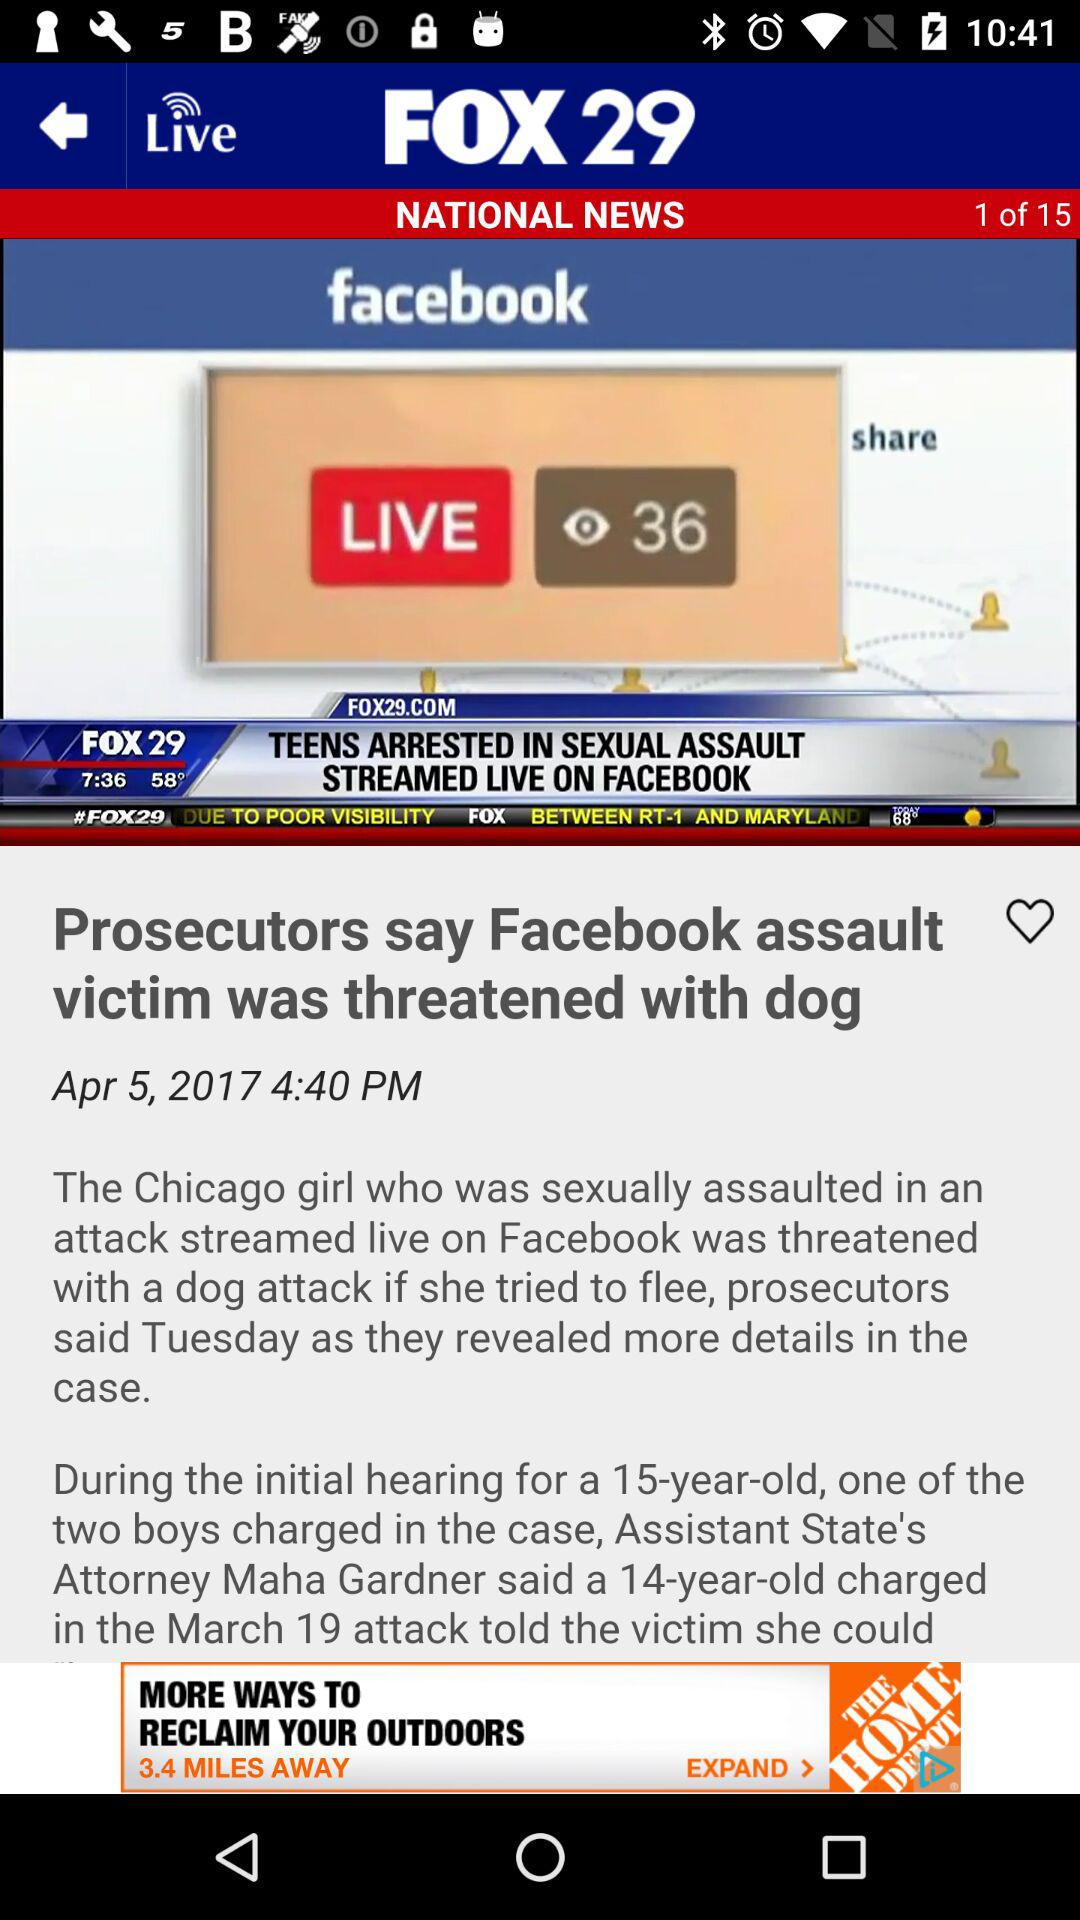What is the date of the news? The date is April 5, 2017. 